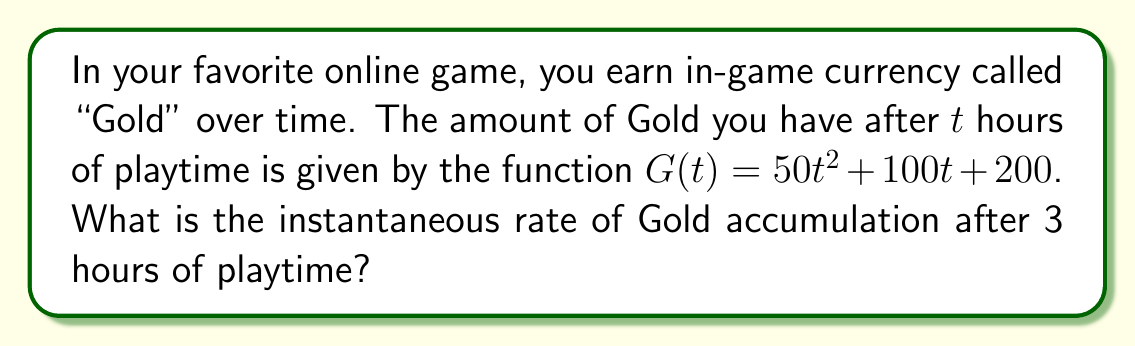Teach me how to tackle this problem. To find the instantaneous rate of Gold accumulation, we need to calculate the derivative of the function $G(t)$ and then evaluate it at $t = 3$. Here's how we do it:

1. The given function is $G(t) = 50t^2 + 100t + 200$

2. To find the derivative, we use the power rule and constant rule:
   $G'(t) = 100t + 100$

3. This derivative $G'(t)$ represents the instantaneous rate of change of Gold with respect to time.

4. To find the rate at 3 hours, we substitute $t = 3$ into $G'(t)$:
   $G'(3) = 100(3) + 100 = 300 + 100 = 400$

Therefore, after 3 hours of playtime, you are accumulating Gold at a rate of 400 Gold per hour.
Answer: 400 Gold per hour 